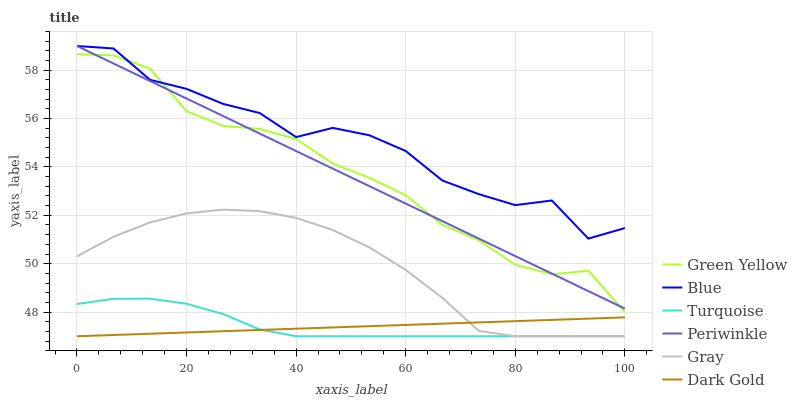Does Dark Gold have the minimum area under the curve?
Answer yes or no. Yes. Does Blue have the maximum area under the curve?
Answer yes or no. Yes. Does Gray have the minimum area under the curve?
Answer yes or no. No. Does Gray have the maximum area under the curve?
Answer yes or no. No. Is Dark Gold the smoothest?
Answer yes or no. Yes. Is Blue the roughest?
Answer yes or no. Yes. Is Gray the smoothest?
Answer yes or no. No. Is Gray the roughest?
Answer yes or no. No. Does Periwinkle have the lowest value?
Answer yes or no. No. Does Periwinkle have the highest value?
Answer yes or no. Yes. Does Gray have the highest value?
Answer yes or no. No. Is Turquoise less than Periwinkle?
Answer yes or no. Yes. Is Green Yellow greater than Dark Gold?
Answer yes or no. Yes. Does Turquoise intersect Periwinkle?
Answer yes or no. No. 